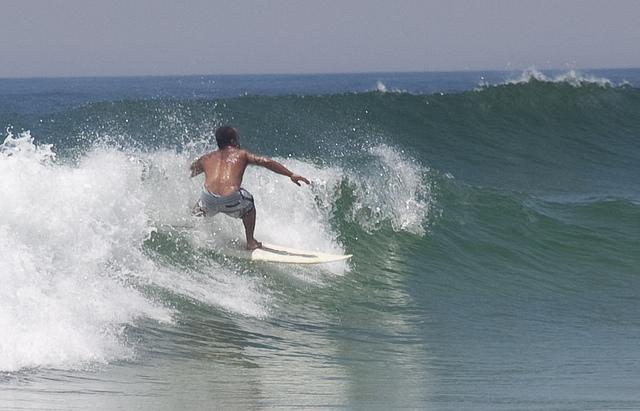What is he wearing?
Short answer required. Shorts. Can you see the horizon?
Concise answer only. Yes. Is there a person surfing?
Answer briefly. Yes. Is the water cold?
Quick response, please. No. How many people are in the background?
Keep it brief. 0. What color are the man's shorts?
Give a very brief answer. Gray. What is the name of the outfit the man is wearing?
Quick response, please. Board shorts. What color shorts does he have on?
Keep it brief. Gray. 